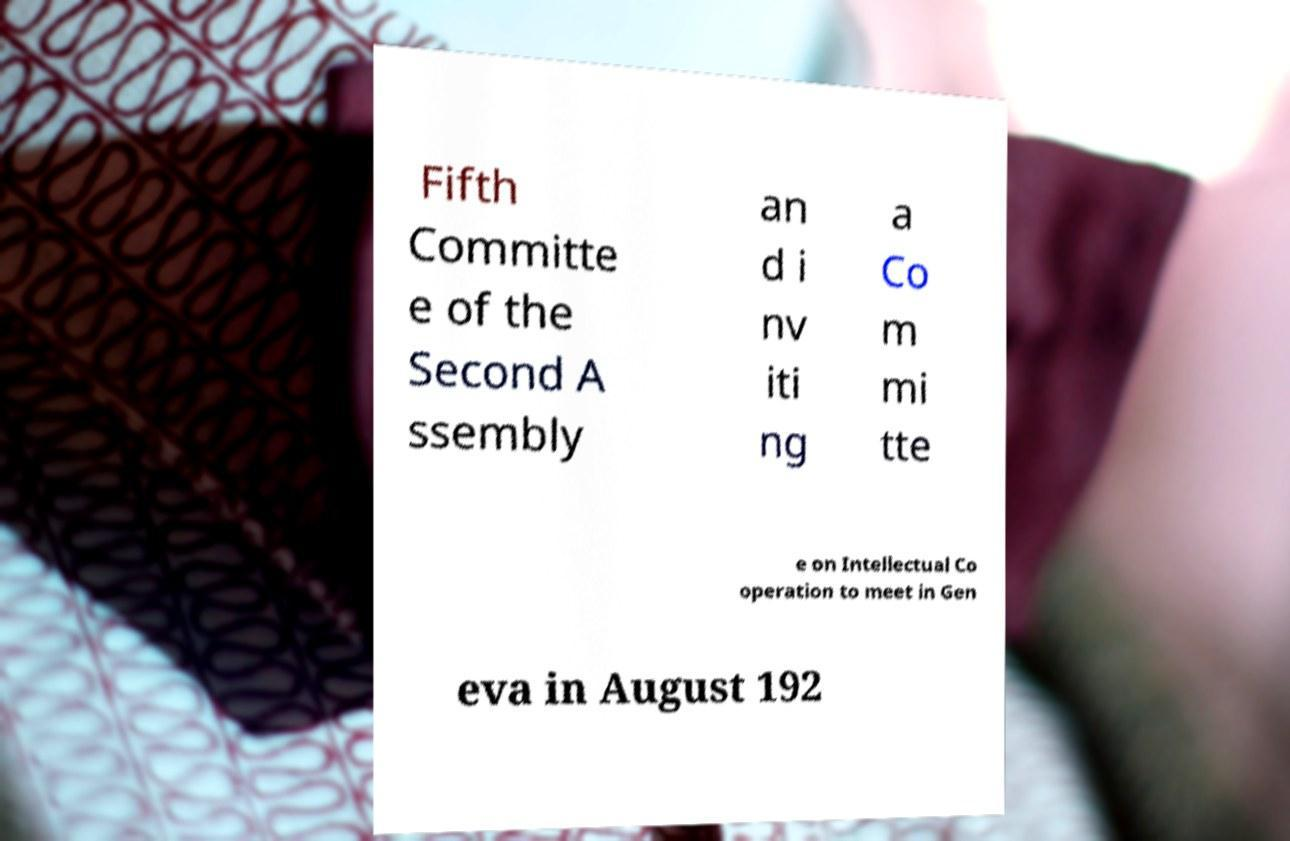I need the written content from this picture converted into text. Can you do that? Fifth Committe e of the Second A ssembly an d i nv iti ng a Co m mi tte e on Intellectual Co operation to meet in Gen eva in August 192 